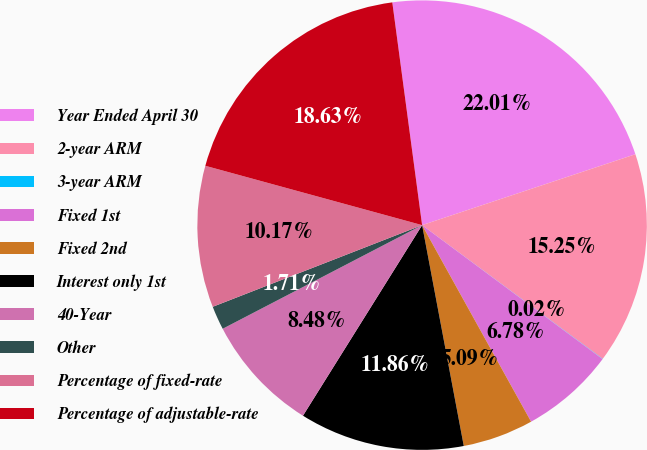Convert chart. <chart><loc_0><loc_0><loc_500><loc_500><pie_chart><fcel>Year Ended April 30<fcel>2-year ARM<fcel>3-year ARM<fcel>Fixed 1st<fcel>Fixed 2nd<fcel>Interest only 1st<fcel>40-Year<fcel>Other<fcel>Percentage of fixed-rate<fcel>Percentage of adjustable-rate<nl><fcel>22.01%<fcel>15.25%<fcel>0.02%<fcel>6.78%<fcel>5.09%<fcel>11.86%<fcel>8.48%<fcel>1.71%<fcel>10.17%<fcel>18.63%<nl></chart> 